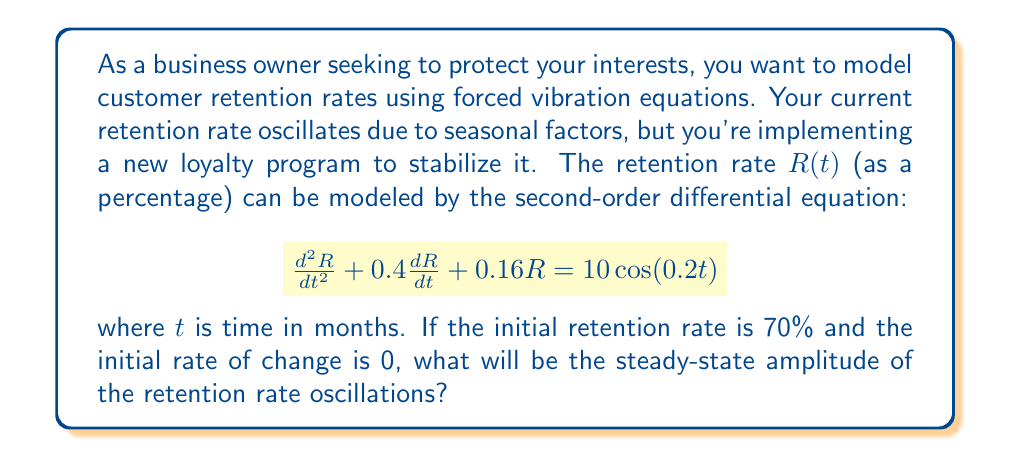What is the answer to this math problem? To solve this problem, we need to follow these steps:

1) First, recognize that this is a forced vibration equation in the form:
   $$\frac{d^2R}{dt^2} + 2\zeta\omega_n\frac{dR}{dt} + \omega_n^2R = F_0\cos(\omega t)$$

2) Identify the parameters:
   $\zeta$ (damping ratio) = 0.2
   $\omega_n$ (natural frequency) = 0.4 rad/month
   $F_0$ (forcing amplitude) = 10
   $\omega$ (forcing frequency) = 0.2 rad/month

3) The steady-state amplitude for a forced vibration is given by:
   $$A = \frac{F_0}{\sqrt{(\omega_n^2 - \omega^2)^2 + (2\zeta\omega_n\omega)^2}}$$

4) Substitute the values:
   $$A = \frac{10}{\sqrt{(0.4^2 - 0.2^2)^2 + (2 \cdot 0.2 \cdot 0.4 \cdot 0.2)^2}}$$

5) Simplify:
   $$A = \frac{10}{\sqrt{(0.16 - 0.04)^2 + (0.032)^2}}$$
   $$A = \frac{10}{\sqrt{0.12^2 + 0.032^2}}$$
   $$A = \frac{10}{\sqrt{0.0144 + 0.001024}}$$
   $$A = \frac{10}{\sqrt{0.015424}}$$
   $$A \approx 80.49$$

6) Therefore, the steady-state amplitude of the retention rate oscillations will be approximately 80.49%.
Answer: 80.49% 